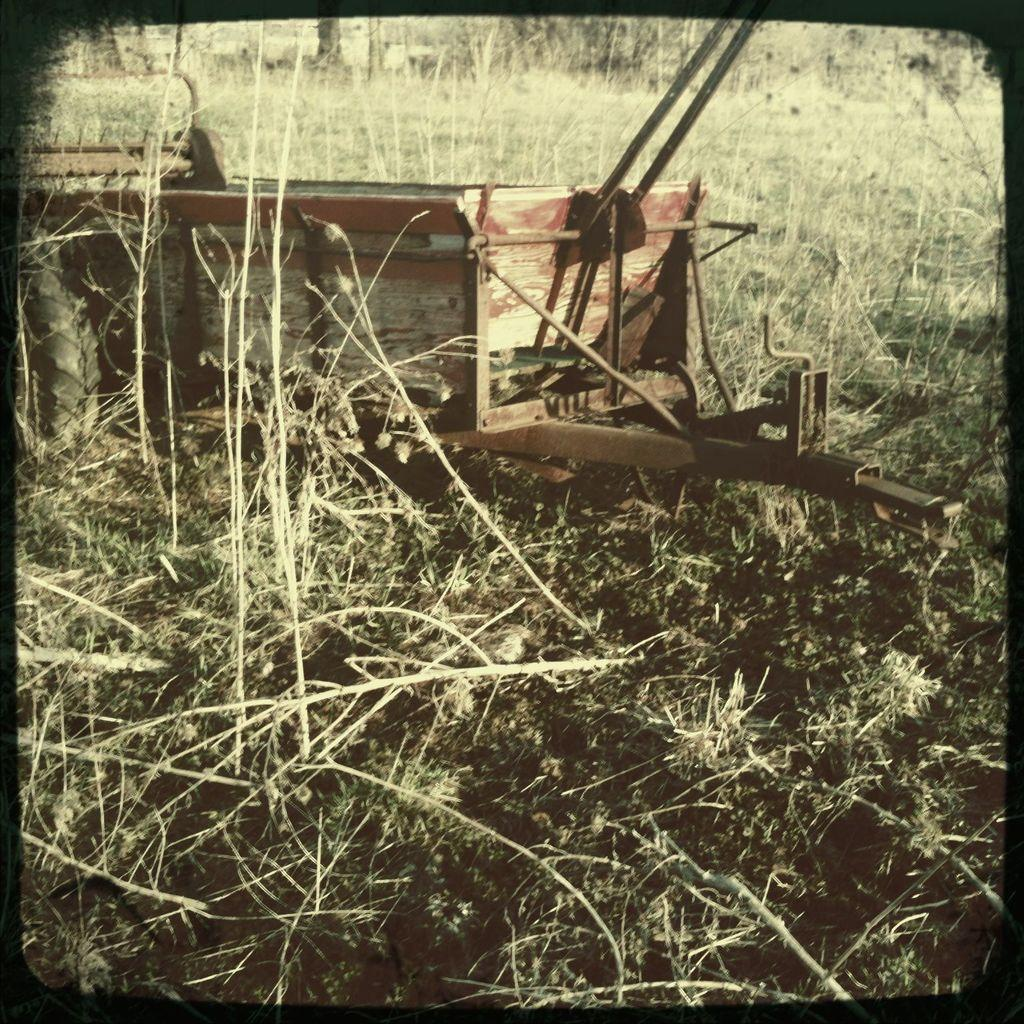What is the main subject of the image? The main subject of the image is a truck. How is the truck positioned in the image? The truck is placed on the ground. What else can be seen on the ground in the image? There are plants on the ground. What is visible in the background of the image? There are trees and an open land visible in the background. Can you tell me which eye the truck is looking at in the image? The truck does not have eyes, so it cannot be looking at any eye in the image. 